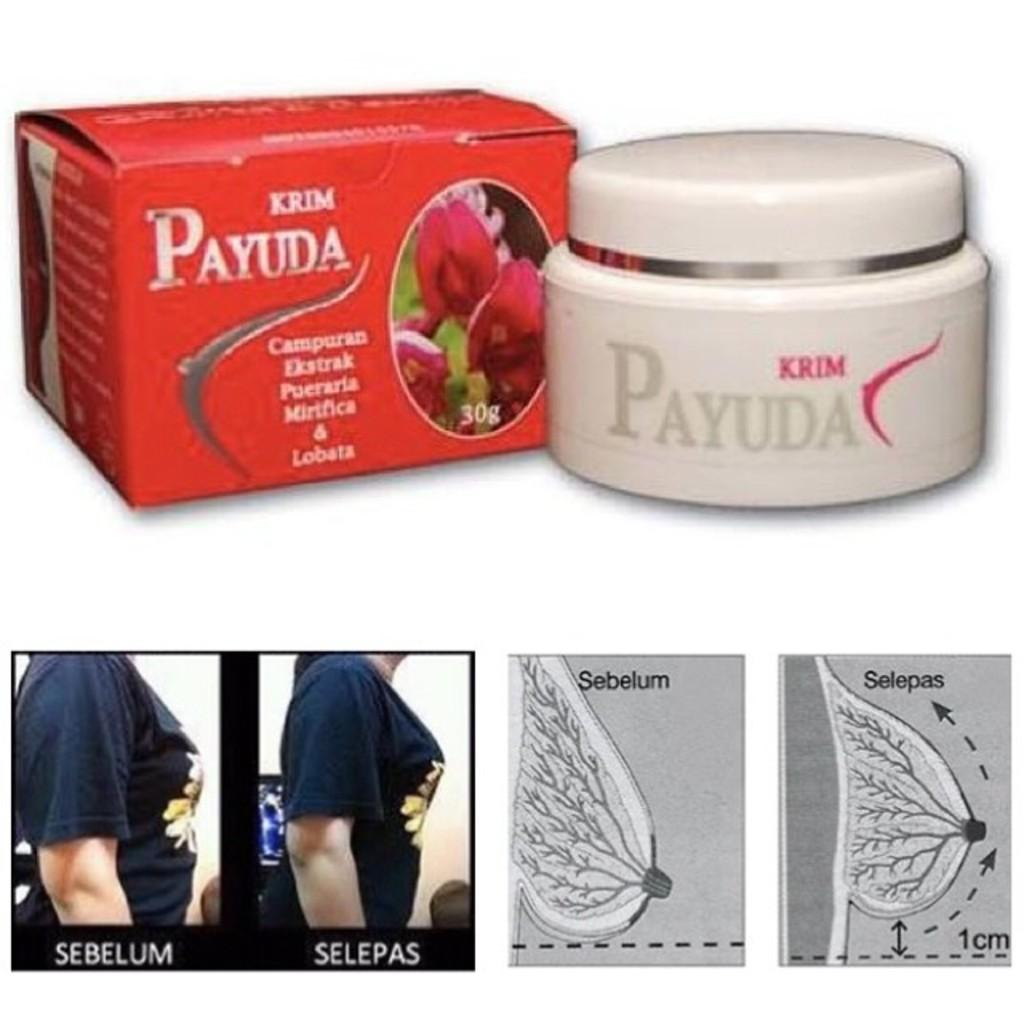Provide a one-sentence caption for the provided image. Cream called Payuda that is supposed to help keep breasts firm. 